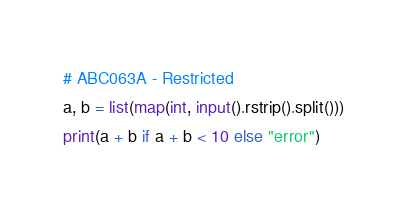<code> <loc_0><loc_0><loc_500><loc_500><_Python_># ABC063A - Restricted
a, b = list(map(int, input().rstrip().split()))
print(a + b if a + b < 10 else "error")</code> 